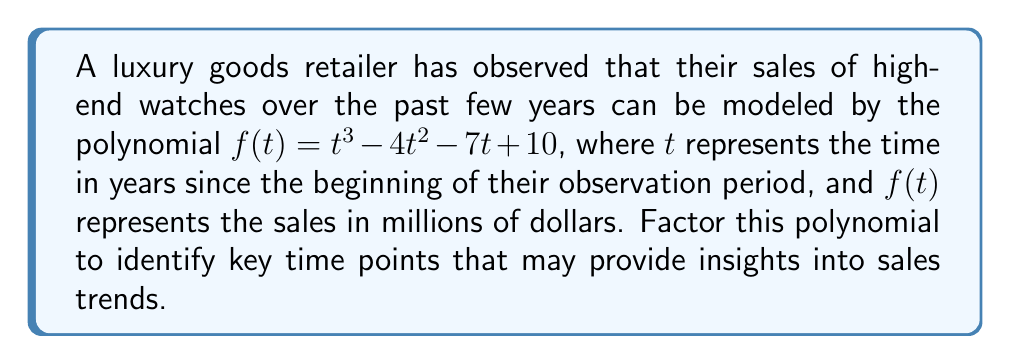What is the answer to this math problem? To factor this polynomial, we'll follow these steps:

1) First, let's check if there are any rational roots using the rational root theorem. The possible rational roots are the factors of the constant term: $\pm 1, \pm 2, \pm 5, \pm 10$.

2) Testing these values, we find that $f(1) = 0$. So $(t-1)$ is a factor.

3) We can use polynomial long division to divide $f(t)$ by $(t-1)$:

   $$\frac{t^3 - 4t^2 - 7t + 10}{t - 1} = t^2 - 3t - 10$$

4) Now we have: $f(t) = (t-1)(t^2 - 3t - 10)$

5) We can factor the quadratic term $t^2 - 3t - 10$ using the quadratic formula or by inspection. It factors to $(t-5)(t+2)$.

6) Therefore, the fully factored polynomial is:

   $$f(t) = (t-1)(t-5)(t+2)$$

This factorization reveals that the sales function has roots at $t = 1$, $t = 5$, and $t = -2$. While $t = -2$ is not relevant in this context (as it's before the observation period), the values $t = 1$ and $t = 5$ represent years where the sales were exactly $0 million, potentially indicating significant events or turning points in the sales trend.
Answer: $(t-1)(t-5)(t+2)$ 